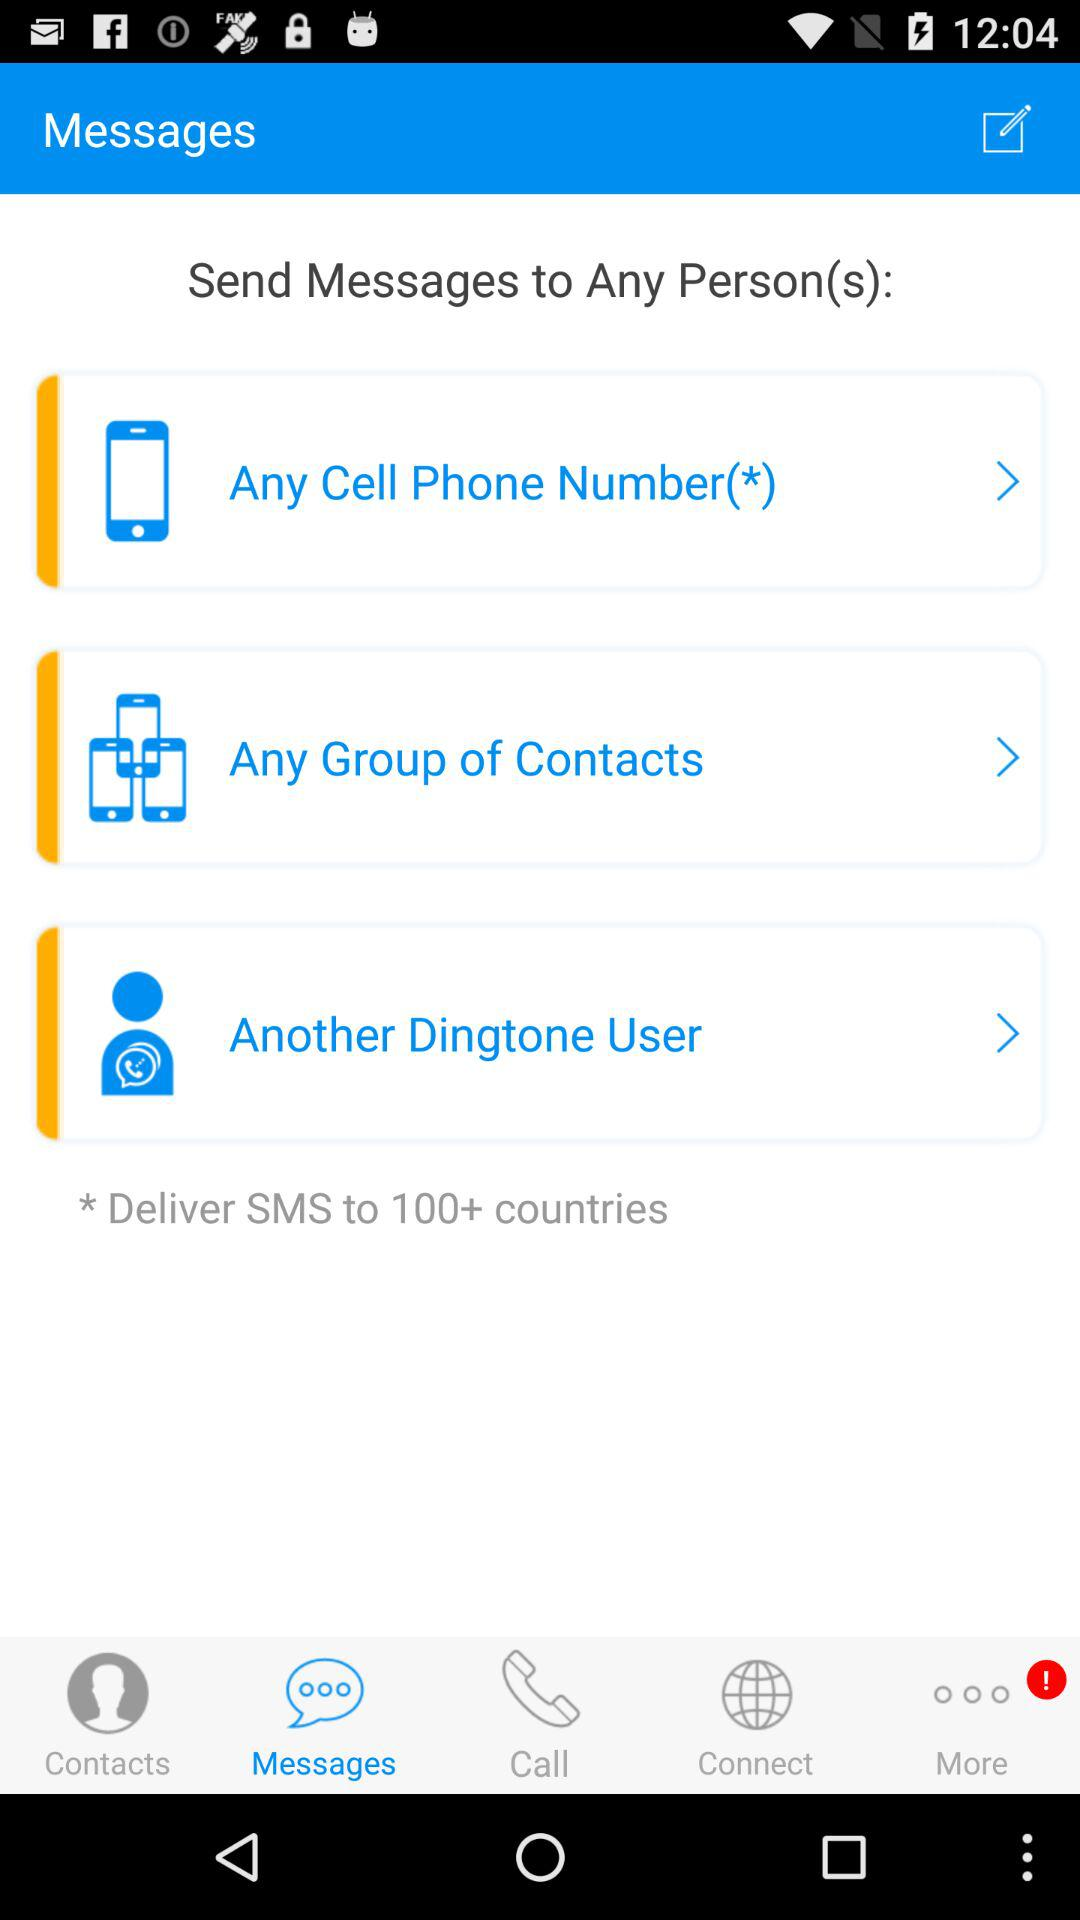Which tab is selected? The selected tab is "Messages". 